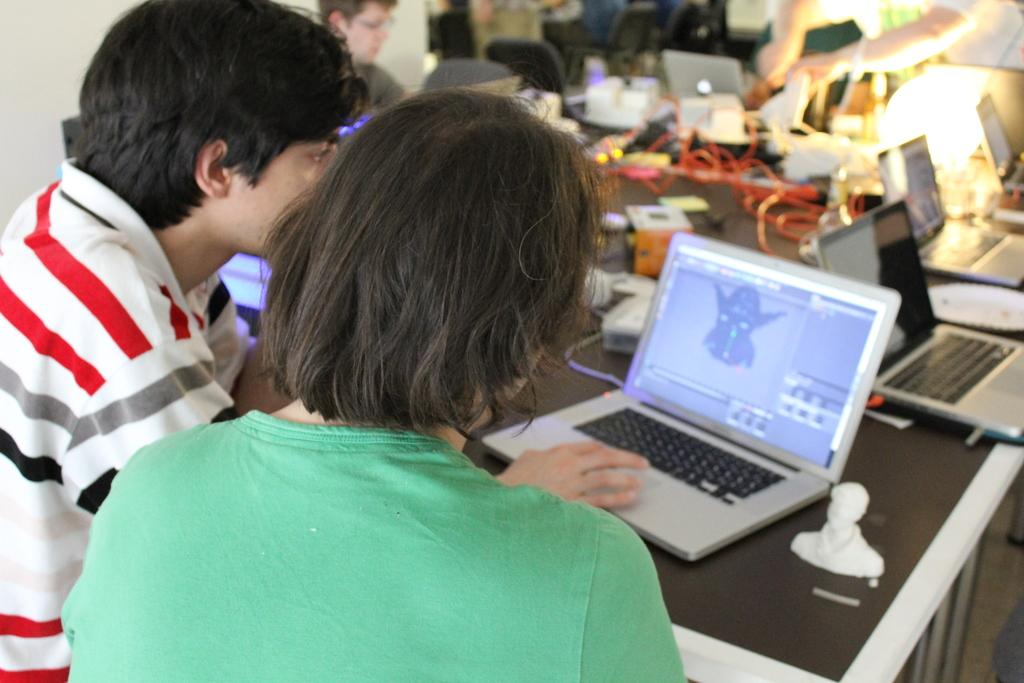What are the people in the image doing? The people in the image are sitting in front of a table. What electronic devices are on the table? There are laptops on the table. What else can be seen on the table besides laptops? There are wires and other objects on the table. Can you describe the background of the image? The background of the image is blurred. What type of winter clothing can be seen on the people in the image? There is no winter clothing visible in the image, as the people are not wearing any. What is the connection between the laptops and the wires on the table? The wires are likely connected to the laptops to provide power or internet access, but the specific connection cannot be determined from the image. 